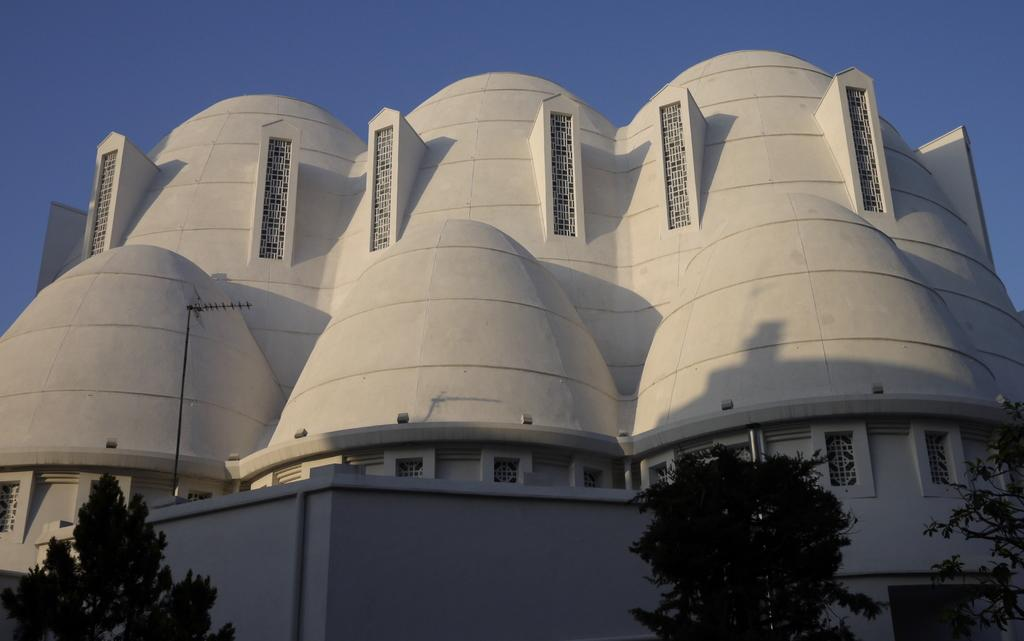What type of structure is present in the image? There is a building in the picture. What can be seen at the bottom of the image? There are trees at the bottom of the picture. What is visible at the top of the image? The sky is visible at the top of the picture. What type of pen is being used to draw the building in the image? There is no pen or drawing activity present in the image; it is a photograph of a building. What holiday is being celebrated in the image? There is no indication of a holiday being celebrated in the image. 